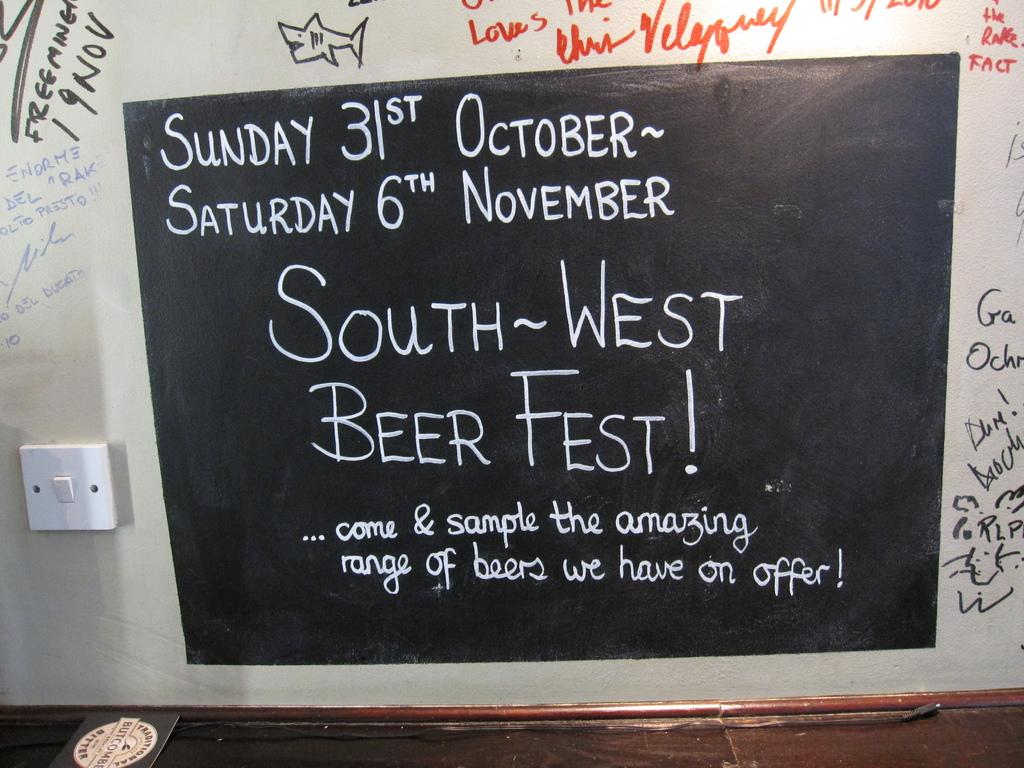<image>
Describe the image concisely. A black square on a white board with the dates for beer fest showing Sunday 31st October~ Saturday 6th November. 